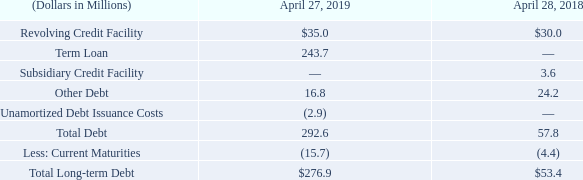10. Debt
A summary of debt is shown below:
Revolving Credit Facility/Term Loan
On September 12, 2018, the Company entered into five-year Amended and Restated Credit Agreement (“Credit Agreement”) with Bank of America, N.A., as Administrative Agent, and Wells Fargo Bank, N.A. The Credit Agreement amends and restates the credit agreement, dated November 18, 2016, among the Company, Bank of America, N.A. and Wells Fargo Bank, N.A. The Credit Agreement consists of a senior unsecured revolving credit facility (“Revolving Credit Facility”) of $200.0 million and a senior unsecured term loan (“Term Loan”) of $250.0 million. In addition, the Company has an option to increase the size of the Revolving Credit Facility and Term Loan by up to an additional $200.0 million. The Credit Agreement is guaranteed by the Company’s wholly-owned U.S. subsidiaries. For the Term Loan, the Company is required to make quarterly principal payments of 1.25% of the original Term Loan ($3.1 million) through maturity, with the remaining balance due on September 12, 2023.
Outstanding borrowings under the Credit Agreement bear interest at variable rates based on the type of borrowing and the Company’s debt to EBITDA financial ratio, as defined. The interest rate on outstanding borrowings under the Credit Agreement was 3.98% at April 27, 2019. The Credit Agreement contains customary representations and warranties, financial covenants, restrictive covenants and events of default. As of April 27, 2019, the Company was in compliance with all the covenants in the Credit Agreement. The fair value of borrowings under the Credit Agreement approximates book value because the interest rate is variable.
Subsidiary Credit Facility
The Company’s subsidiary, Pacific Insight, is a party to a credit agreement with the Bank of Montreal which provides a credit facility in the maximum principal amount of C$10.0 million, with an option to increase the principal amount by up to an additional C$5.0 million. Availability under the facility is based on a percentage of eligible accounts receivable and finished goods inventory balances. Interest is calculated at a base rate plus margin, as defined. In addition, Pacific Insight was a party to a credit agreement with Roynat which was terminated during the second quarter of fiscal 2019. Total repayments under the credit agreement with Roynat were $3.8 million in fiscal 2019, including a prepayment fee of $0.1 million.
Other Debt
The Company’s subsidiary, Procoplast, has debt that consists of eighteen notes with maturities ranging from 2019 to 2031. The weighted-average interest rate was approximately 1.5% at April 27, 2019 and $3.2 million of the debt was classified as short-term. The fair value of other debt was $16.3 million at April 27, 2019 and was based on Level 2 inputs on a nonrecurring basis.
Unamortized Debt Issuance Costs
The Company paid debt issuance costs of $3.1 million on September 12, 2018 in connection with the Credit Agreement. The debt issuance costs are being amortized over the five-year term of the Credit Agreement.
What was the weighted-average interest rate in 2019? 1.5%. What was the debt issuance cost in 2018? $3.1 million. What was the Revolving Credit Facility in 2019 and 2018 respectively?
Answer scale should be: million. 35.0, 30.0. What was the change in the Revolving Credit Facility from 2018 to 2019?
Answer scale should be: million. 35.0 - 30.0
Answer: 5. What was the average Term loan for 2018 and 2019?
Answer scale should be: million. (243.7 + 0) / 2
Answer: 121.85. In which year was Other Debt less than 20.0 million? Locate and analyze other debt in row 8
answer: 2019. 